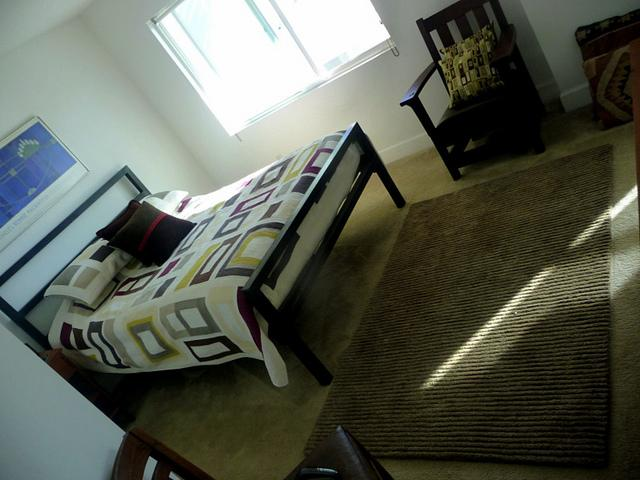What color is the painting on the wall behind the bed stand? blue 